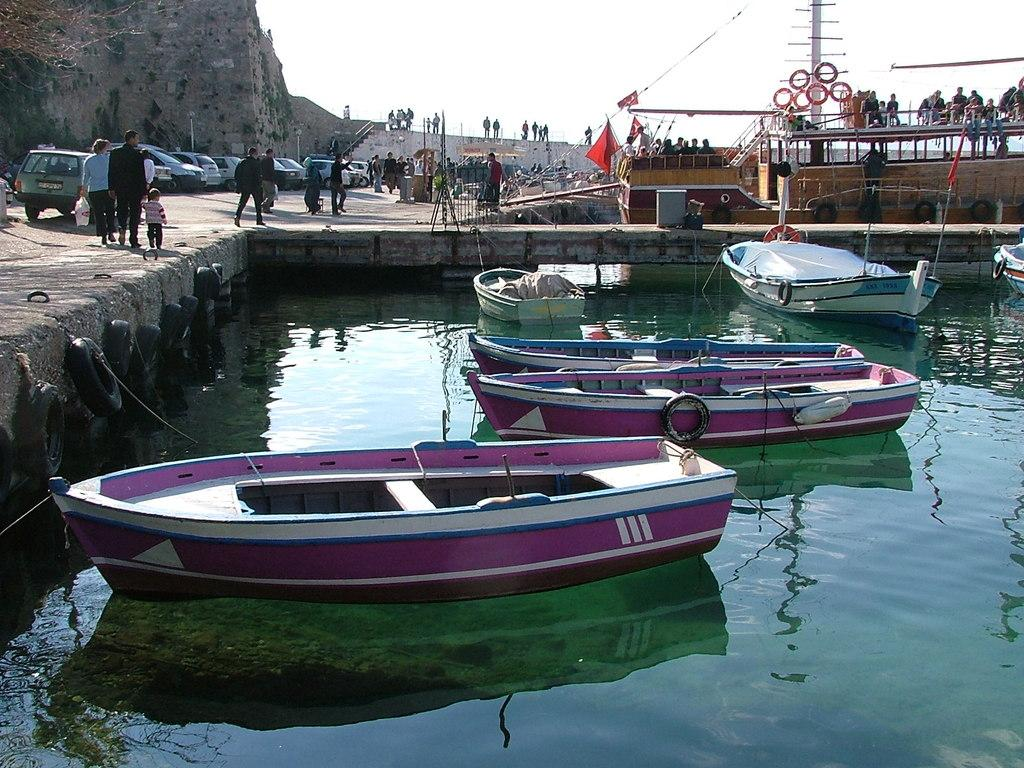What is happening on the water in the image? There are boats on the water in the image. What can be seen in the background of the image? There are vehicles, people standing on the ground, a boatyard, and the sky visible in the background of the image. Can you describe the objects present in the background of the image? There are other objects present in the background of the image, but their specific details are not mentioned in the provided facts. What type of operation is being performed on the pot in the image? There is no pot present in the image, and therefore no operation is being performed on it. What color is the powder that is being mixed in the image? There is no powder or mixing activity present in the image. 